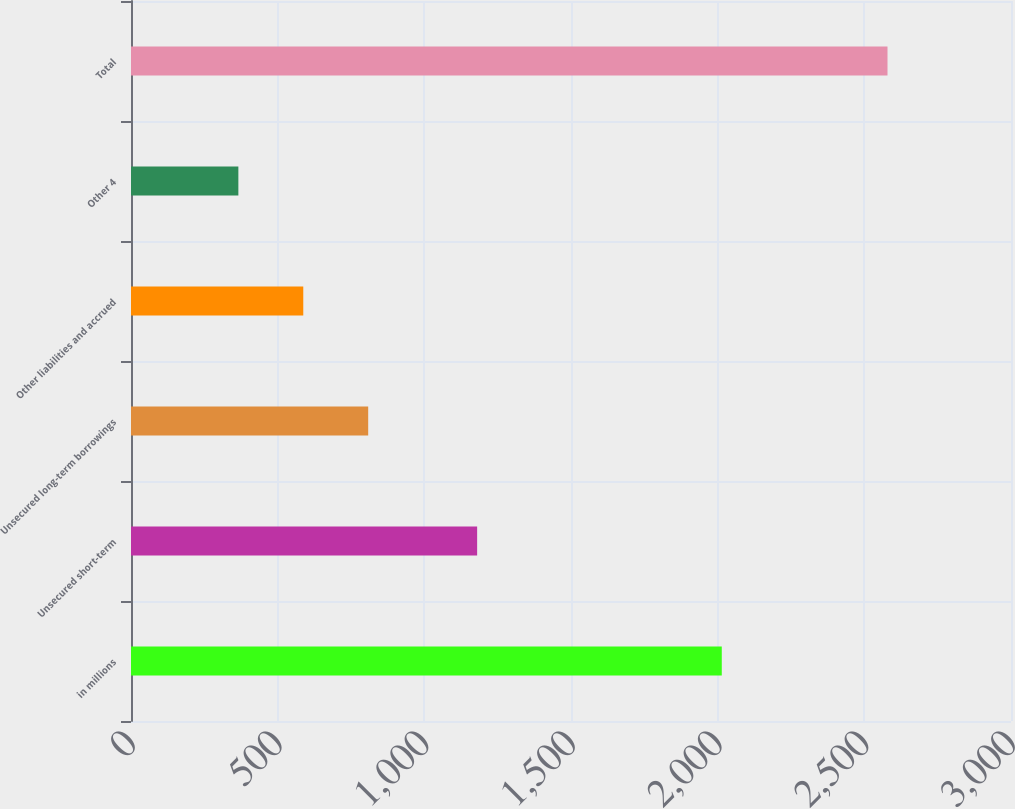Convert chart. <chart><loc_0><loc_0><loc_500><loc_500><bar_chart><fcel>in millions<fcel>Unsecured short-term<fcel>Unsecured long-term borrowings<fcel>Other liabilities and accrued<fcel>Other 4<fcel>Total<nl><fcel>2014<fcel>1180<fcel>808.6<fcel>587.3<fcel>366<fcel>2579<nl></chart> 